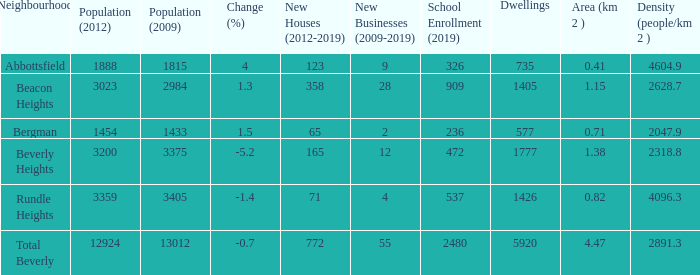How many Dwellings does Beverly Heights have that have a change percent larger than -5.2? None. 